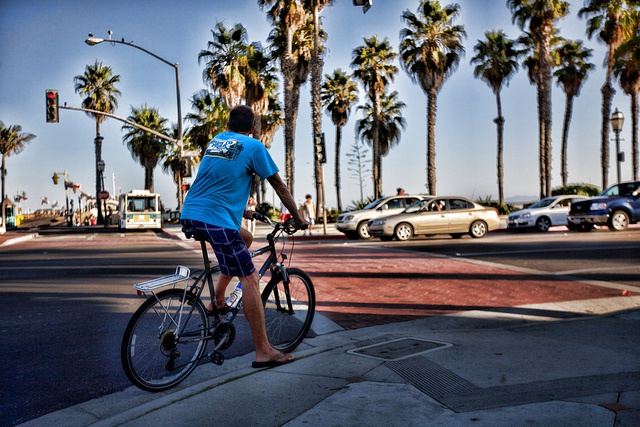Describe the objects in this image and their specific colors. I can see bicycle in darkblue, black, navy, and gray tones, people in darkblue, black, blue, maroon, and navy tones, car in darkblue, ivory, black, and tan tones, truck in darkblue, black, navy, gray, and darkgray tones, and car in darkblue, black, darkgray, lightgray, and gray tones in this image. 